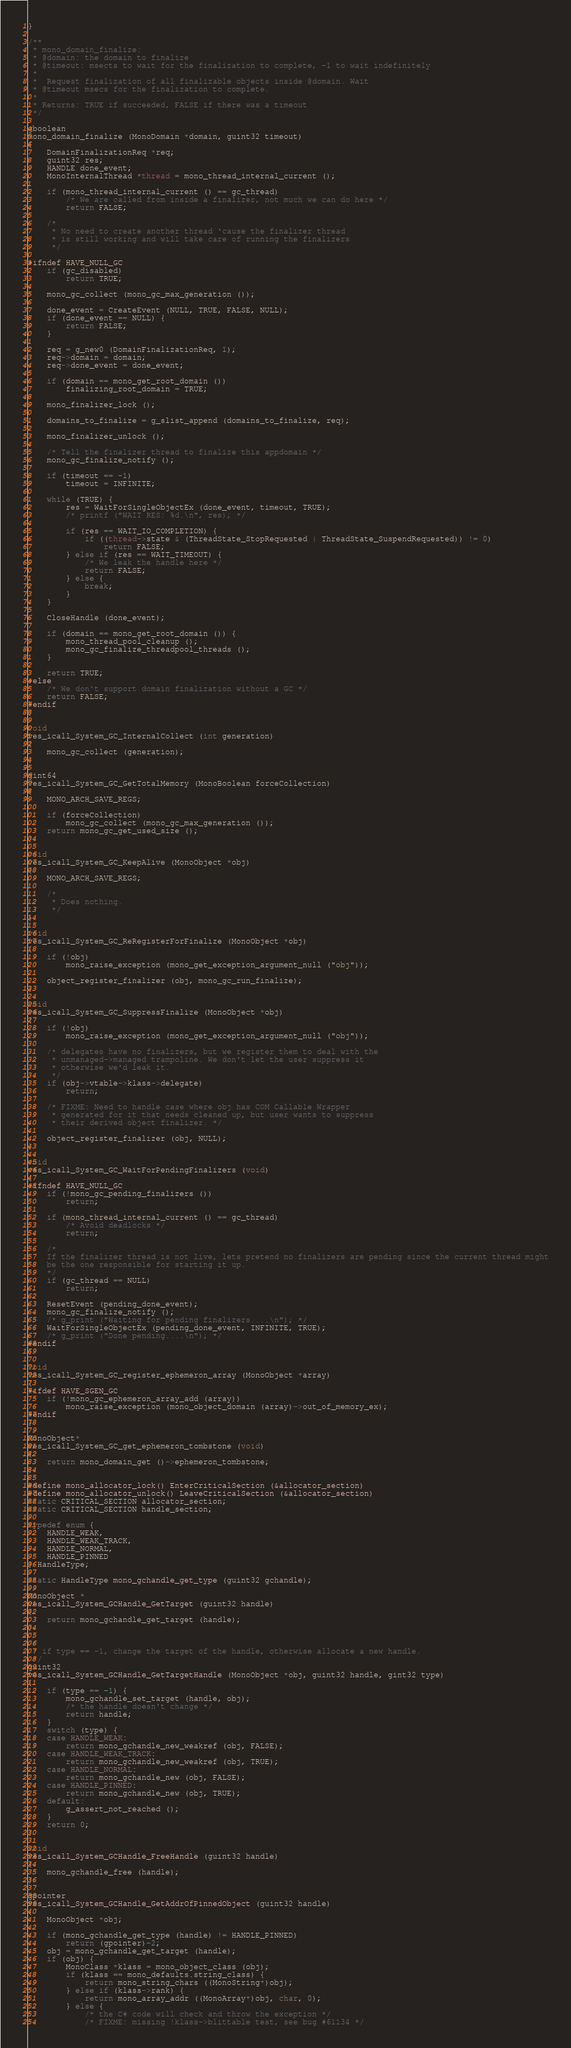<code> <loc_0><loc_0><loc_500><loc_500><_C_>}

/**
 * mono_domain_finalize:
 * @domain: the domain to finalize
 * @timeout: msects to wait for the finalization to complete, -1 to wait indefinitely
 *
 *  Request finalization of all finalizable objects inside @domain. Wait
 * @timeout msecs for the finalization to complete.
 *
 * Returns: TRUE if succeeded, FALSE if there was a timeout
 */

gboolean
mono_domain_finalize (MonoDomain *domain, guint32 timeout) 
{
	DomainFinalizationReq *req;
	guint32 res;
	HANDLE done_event;
	MonoInternalThread *thread = mono_thread_internal_current ();

	if (mono_thread_internal_current () == gc_thread)
		/* We are called from inside a finalizer, not much we can do here */
		return FALSE;

	/* 
	 * No need to create another thread 'cause the finalizer thread
	 * is still working and will take care of running the finalizers
	 */ 
	
#ifndef HAVE_NULL_GC
	if (gc_disabled)
		return TRUE;

	mono_gc_collect (mono_gc_max_generation ());

	done_event = CreateEvent (NULL, TRUE, FALSE, NULL);
	if (done_event == NULL) {
		return FALSE;
	}

	req = g_new0 (DomainFinalizationReq, 1);
	req->domain = domain;
	req->done_event = done_event;

	if (domain == mono_get_root_domain ())
		finalizing_root_domain = TRUE;
	
	mono_finalizer_lock ();

	domains_to_finalize = g_slist_append (domains_to_finalize, req);

	mono_finalizer_unlock ();

	/* Tell the finalizer thread to finalize this appdomain */
	mono_gc_finalize_notify ();

	if (timeout == -1)
		timeout = INFINITE;

	while (TRUE) {
		res = WaitForSingleObjectEx (done_event, timeout, TRUE);
		/* printf ("WAIT RES: %d.\n", res); */

		if (res == WAIT_IO_COMPLETION) {
			if ((thread->state & (ThreadState_StopRequested | ThreadState_SuspendRequested)) != 0)
				return FALSE;
		} else if (res == WAIT_TIMEOUT) {
			/* We leak the handle here */
			return FALSE;
		} else {
			break;
		}
	}

	CloseHandle (done_event);

	if (domain == mono_get_root_domain ()) {
		mono_thread_pool_cleanup ();
		mono_gc_finalize_threadpool_threads ();
	}

	return TRUE;
#else
	/* We don't support domain finalization without a GC */
	return FALSE;
#endif
}

void
ves_icall_System_GC_InternalCollect (int generation)
{
	mono_gc_collect (generation);
}

gint64
ves_icall_System_GC_GetTotalMemory (MonoBoolean forceCollection)
{
	MONO_ARCH_SAVE_REGS;

	if (forceCollection)
		mono_gc_collect (mono_gc_max_generation ());
	return mono_gc_get_used_size ();
}

void
ves_icall_System_GC_KeepAlive (MonoObject *obj)
{
	MONO_ARCH_SAVE_REGS;

	/*
	 * Does nothing.
	 */
}

void
ves_icall_System_GC_ReRegisterForFinalize (MonoObject *obj)
{
	if (!obj)
		mono_raise_exception (mono_get_exception_argument_null ("obj"));

	object_register_finalizer (obj, mono_gc_run_finalize);
}

void
ves_icall_System_GC_SuppressFinalize (MonoObject *obj)
{
	if (!obj)
		mono_raise_exception (mono_get_exception_argument_null ("obj"));

	/* delegates have no finalizers, but we register them to deal with the
	 * unmanaged->managed trampoline. We don't let the user suppress it
	 * otherwise we'd leak it.
	 */
	if (obj->vtable->klass->delegate)
		return;

	/* FIXME: Need to handle case where obj has COM Callable Wrapper
	 * generated for it that needs cleaned up, but user wants to suppress
	 * their derived object finalizer. */

	object_register_finalizer (obj, NULL);
}

void
ves_icall_System_GC_WaitForPendingFinalizers (void)
{
#ifndef HAVE_NULL_GC
	if (!mono_gc_pending_finalizers ())
		return;

	if (mono_thread_internal_current () == gc_thread)
		/* Avoid deadlocks */
		return;

	/*
	If the finalizer thread is not live, lets pretend no finalizers are pending since the current thread might
	be the one responsible for starting it up.
	*/
	if (gc_thread == NULL)
		return;

	ResetEvent (pending_done_event);
	mono_gc_finalize_notify ();
	/* g_print ("Waiting for pending finalizers....\n"); */
	WaitForSingleObjectEx (pending_done_event, INFINITE, TRUE);
	/* g_print ("Done pending....\n"); */
#endif
}

void
ves_icall_System_GC_register_ephemeron_array (MonoObject *array)
{
#ifdef HAVE_SGEN_GC
	if (!mono_gc_ephemeron_array_add (array))
		mono_raise_exception (mono_object_domain (array)->out_of_memory_ex);
#endif
}

MonoObject*
ves_icall_System_GC_get_ephemeron_tombstone (void)
{
	return mono_domain_get ()->ephemeron_tombstone;
}

#define mono_allocator_lock() EnterCriticalSection (&allocator_section)
#define mono_allocator_unlock() LeaveCriticalSection (&allocator_section)
static CRITICAL_SECTION allocator_section;
static CRITICAL_SECTION handle_section;

typedef enum {
	HANDLE_WEAK,
	HANDLE_WEAK_TRACK,
	HANDLE_NORMAL,
	HANDLE_PINNED
} HandleType;

static HandleType mono_gchandle_get_type (guint32 gchandle);

MonoObject *
ves_icall_System_GCHandle_GetTarget (guint32 handle)
{
	return mono_gchandle_get_target (handle);
}

/*
 * if type == -1, change the target of the handle, otherwise allocate a new handle.
 */
guint32
ves_icall_System_GCHandle_GetTargetHandle (MonoObject *obj, guint32 handle, gint32 type)
{
	if (type == -1) {
		mono_gchandle_set_target (handle, obj);
		/* the handle doesn't change */
		return handle;
	}
	switch (type) {
	case HANDLE_WEAK:
		return mono_gchandle_new_weakref (obj, FALSE);
	case HANDLE_WEAK_TRACK:
		return mono_gchandle_new_weakref (obj, TRUE);
	case HANDLE_NORMAL:
		return mono_gchandle_new (obj, FALSE);
	case HANDLE_PINNED:
		return mono_gchandle_new (obj, TRUE);
	default:
		g_assert_not_reached ();
	}
	return 0;
}

void
ves_icall_System_GCHandle_FreeHandle (guint32 handle)
{
	mono_gchandle_free (handle);
}

gpointer
ves_icall_System_GCHandle_GetAddrOfPinnedObject (guint32 handle)
{
	MonoObject *obj;

	if (mono_gchandle_get_type (handle) != HANDLE_PINNED)
		return (gpointer)-2;
	obj = mono_gchandle_get_target (handle);
	if (obj) {
		MonoClass *klass = mono_object_class (obj);
		if (klass == mono_defaults.string_class) {
			return mono_string_chars ((MonoString*)obj);
		} else if (klass->rank) {
			return mono_array_addr ((MonoArray*)obj, char, 0);
		} else {
			/* the C# code will check and throw the exception */
			/* FIXME: missing !klass->blittable test, see bug #61134 */</code> 